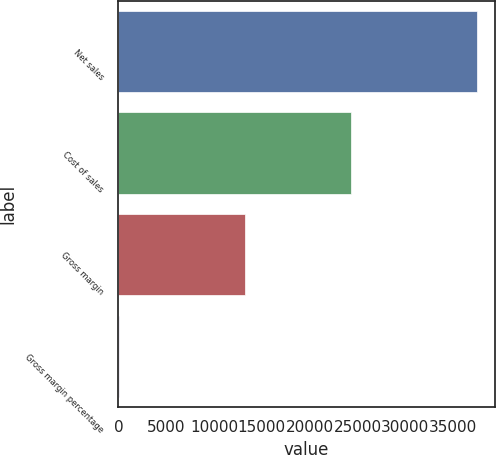Convert chart to OTSL. <chart><loc_0><loc_0><loc_500><loc_500><bar_chart><fcel>Net sales<fcel>Cost of sales<fcel>Gross margin<fcel>Gross margin percentage<nl><fcel>37491<fcel>24294<fcel>13197<fcel>35.2<nl></chart> 